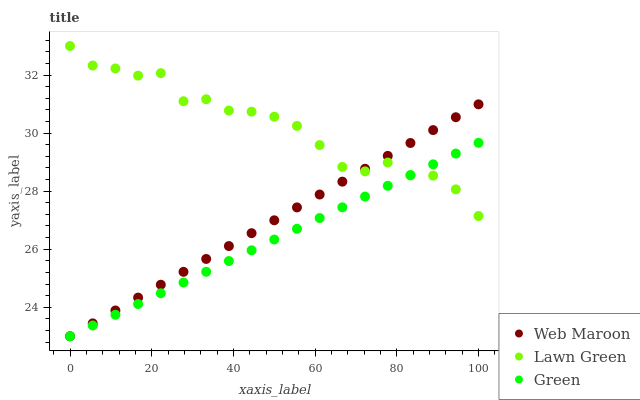Does Green have the minimum area under the curve?
Answer yes or no. Yes. Does Lawn Green have the maximum area under the curve?
Answer yes or no. Yes. Does Web Maroon have the minimum area under the curve?
Answer yes or no. No. Does Web Maroon have the maximum area under the curve?
Answer yes or no. No. Is Green the smoothest?
Answer yes or no. Yes. Is Lawn Green the roughest?
Answer yes or no. Yes. Is Web Maroon the smoothest?
Answer yes or no. No. Is Web Maroon the roughest?
Answer yes or no. No. Does Green have the lowest value?
Answer yes or no. Yes. Does Lawn Green have the highest value?
Answer yes or no. Yes. Does Web Maroon have the highest value?
Answer yes or no. No. Does Green intersect Lawn Green?
Answer yes or no. Yes. Is Green less than Lawn Green?
Answer yes or no. No. Is Green greater than Lawn Green?
Answer yes or no. No. 